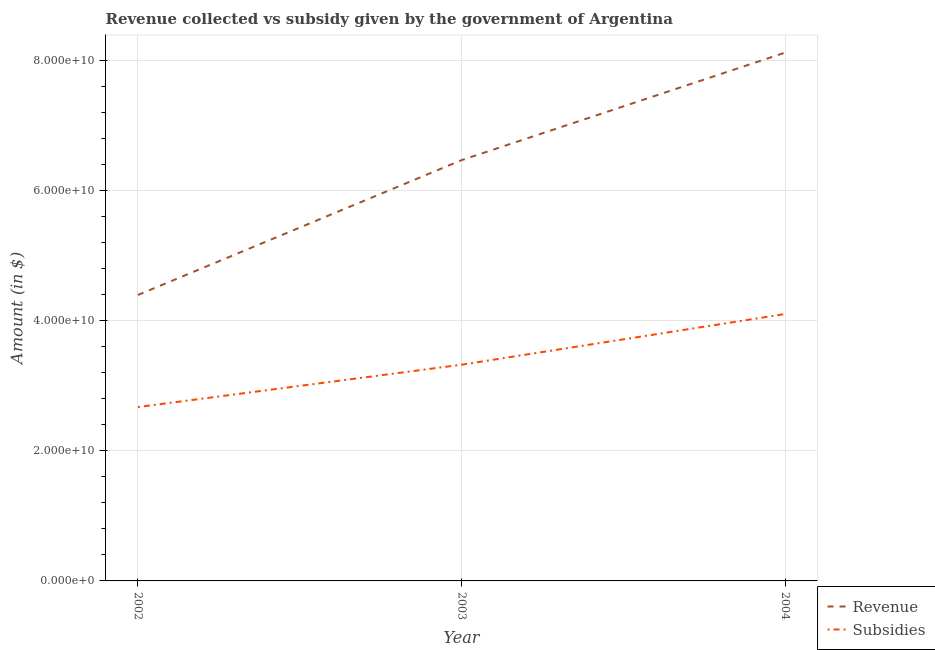Is the number of lines equal to the number of legend labels?
Offer a terse response. Yes. What is the amount of subsidies given in 2002?
Give a very brief answer. 2.67e+1. Across all years, what is the maximum amount of subsidies given?
Make the answer very short. 4.10e+1. Across all years, what is the minimum amount of subsidies given?
Ensure brevity in your answer.  2.67e+1. In which year was the amount of revenue collected minimum?
Keep it short and to the point. 2002. What is the total amount of subsidies given in the graph?
Provide a succinct answer. 1.01e+11. What is the difference between the amount of subsidies given in 2002 and that in 2003?
Your answer should be very brief. -6.51e+09. What is the difference between the amount of subsidies given in 2003 and the amount of revenue collected in 2002?
Provide a succinct answer. -1.07e+1. What is the average amount of subsidies given per year?
Offer a very short reply. 3.37e+1. In the year 2003, what is the difference between the amount of subsidies given and amount of revenue collected?
Keep it short and to the point. -3.14e+1. What is the ratio of the amount of subsidies given in 2002 to that in 2003?
Offer a very short reply. 0.8. Is the amount of revenue collected in 2003 less than that in 2004?
Offer a very short reply. Yes. What is the difference between the highest and the second highest amount of subsidies given?
Provide a short and direct response. 7.79e+09. What is the difference between the highest and the lowest amount of revenue collected?
Provide a succinct answer. 3.72e+1. In how many years, is the amount of subsidies given greater than the average amount of subsidies given taken over all years?
Offer a very short reply. 1. Does the amount of subsidies given monotonically increase over the years?
Ensure brevity in your answer.  Yes. How many lines are there?
Make the answer very short. 2. Does the graph contain any zero values?
Give a very brief answer. No. How are the legend labels stacked?
Provide a short and direct response. Vertical. What is the title of the graph?
Your response must be concise. Revenue collected vs subsidy given by the government of Argentina. Does "Number of departures" appear as one of the legend labels in the graph?
Your answer should be compact. No. What is the label or title of the Y-axis?
Provide a succinct answer. Amount (in $). What is the Amount (in $) of Revenue in 2002?
Keep it short and to the point. 4.39e+1. What is the Amount (in $) of Subsidies in 2002?
Give a very brief answer. 2.67e+1. What is the Amount (in $) of Revenue in 2003?
Keep it short and to the point. 6.47e+1. What is the Amount (in $) of Subsidies in 2003?
Your response must be concise. 3.32e+1. What is the Amount (in $) of Revenue in 2004?
Provide a short and direct response. 8.12e+1. What is the Amount (in $) in Subsidies in 2004?
Make the answer very short. 4.10e+1. Across all years, what is the maximum Amount (in $) in Revenue?
Your answer should be very brief. 8.12e+1. Across all years, what is the maximum Amount (in $) of Subsidies?
Offer a terse response. 4.10e+1. Across all years, what is the minimum Amount (in $) of Revenue?
Offer a very short reply. 4.39e+1. Across all years, what is the minimum Amount (in $) of Subsidies?
Your answer should be compact. 2.67e+1. What is the total Amount (in $) of Revenue in the graph?
Give a very brief answer. 1.90e+11. What is the total Amount (in $) in Subsidies in the graph?
Provide a succinct answer. 1.01e+11. What is the difference between the Amount (in $) of Revenue in 2002 and that in 2003?
Ensure brevity in your answer.  -2.07e+1. What is the difference between the Amount (in $) of Subsidies in 2002 and that in 2003?
Make the answer very short. -6.51e+09. What is the difference between the Amount (in $) in Revenue in 2002 and that in 2004?
Offer a terse response. -3.72e+1. What is the difference between the Amount (in $) in Subsidies in 2002 and that in 2004?
Offer a terse response. -1.43e+1. What is the difference between the Amount (in $) of Revenue in 2003 and that in 2004?
Provide a short and direct response. -1.65e+1. What is the difference between the Amount (in $) of Subsidies in 2003 and that in 2004?
Offer a very short reply. -7.79e+09. What is the difference between the Amount (in $) of Revenue in 2002 and the Amount (in $) of Subsidies in 2003?
Provide a short and direct response. 1.07e+1. What is the difference between the Amount (in $) of Revenue in 2002 and the Amount (in $) of Subsidies in 2004?
Provide a short and direct response. 2.92e+09. What is the difference between the Amount (in $) in Revenue in 2003 and the Amount (in $) in Subsidies in 2004?
Make the answer very short. 2.36e+1. What is the average Amount (in $) in Revenue per year?
Provide a succinct answer. 6.33e+1. What is the average Amount (in $) of Subsidies per year?
Make the answer very short. 3.37e+1. In the year 2002, what is the difference between the Amount (in $) of Revenue and Amount (in $) of Subsidies?
Offer a terse response. 1.72e+1. In the year 2003, what is the difference between the Amount (in $) in Revenue and Amount (in $) in Subsidies?
Offer a terse response. 3.14e+1. In the year 2004, what is the difference between the Amount (in $) in Revenue and Amount (in $) in Subsidies?
Provide a succinct answer. 4.02e+1. What is the ratio of the Amount (in $) of Revenue in 2002 to that in 2003?
Provide a short and direct response. 0.68. What is the ratio of the Amount (in $) of Subsidies in 2002 to that in 2003?
Keep it short and to the point. 0.8. What is the ratio of the Amount (in $) of Revenue in 2002 to that in 2004?
Your answer should be very brief. 0.54. What is the ratio of the Amount (in $) in Subsidies in 2002 to that in 2004?
Keep it short and to the point. 0.65. What is the ratio of the Amount (in $) in Revenue in 2003 to that in 2004?
Your answer should be compact. 0.8. What is the ratio of the Amount (in $) of Subsidies in 2003 to that in 2004?
Your answer should be compact. 0.81. What is the difference between the highest and the second highest Amount (in $) in Revenue?
Ensure brevity in your answer.  1.65e+1. What is the difference between the highest and the second highest Amount (in $) of Subsidies?
Keep it short and to the point. 7.79e+09. What is the difference between the highest and the lowest Amount (in $) in Revenue?
Ensure brevity in your answer.  3.72e+1. What is the difference between the highest and the lowest Amount (in $) of Subsidies?
Offer a terse response. 1.43e+1. 